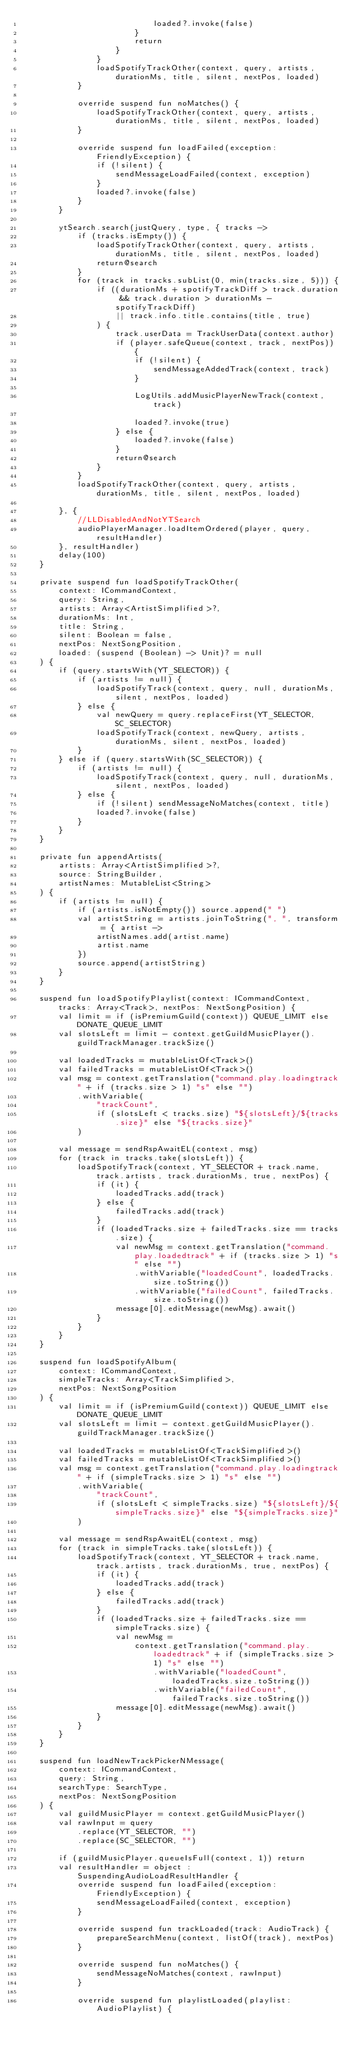<code> <loc_0><loc_0><loc_500><loc_500><_Kotlin_>                            loaded?.invoke(false)
                        }
                        return
                    }
                }
                loadSpotifyTrackOther(context, query, artists, durationMs, title, silent, nextPos, loaded)
            }

            override suspend fun noMatches() {
                loadSpotifyTrackOther(context, query, artists, durationMs, title, silent, nextPos, loaded)
            }

            override suspend fun loadFailed(exception: FriendlyException) {
                if (!silent) {
                    sendMessageLoadFailed(context, exception)
                }
                loaded?.invoke(false)
            }
        }

        ytSearch.search(justQuery, type, { tracks ->
            if (tracks.isEmpty()) {
                loadSpotifyTrackOther(context, query, artists, durationMs, title, silent, nextPos, loaded)
                return@search
            }
            for (track in tracks.subList(0, min(tracks.size, 5))) {
                if ((durationMs + spotifyTrackDiff > track.duration && track.duration > durationMs - spotifyTrackDiff)
                    || track.info.title.contains(title, true)
                ) {
                    track.userData = TrackUserData(context.author)
                    if (player.safeQueue(context, track, nextPos)) {
                        if (!silent) {
                            sendMessageAddedTrack(context, track)
                        }

                        LogUtils.addMusicPlayerNewTrack(context, track)

                        loaded?.invoke(true)
                    } else {
                        loaded?.invoke(false)
                    }
                    return@search
                }
            }
            loadSpotifyTrackOther(context, query, artists, durationMs, title, silent, nextPos, loaded)

        }, {
            //LLDisabledAndNotYTSearch
            audioPlayerManager.loadItemOrdered(player, query, resultHandler)
        }, resultHandler)
        delay(100)
    }

    private suspend fun loadSpotifyTrackOther(
        context: ICommandContext,
        query: String,
        artists: Array<ArtistSimplified>?,
        durationMs: Int,
        title: String,
        silent: Boolean = false,
        nextPos: NextSongPosition,
        loaded: (suspend (Boolean) -> Unit)? = null
    ) {
        if (query.startsWith(YT_SELECTOR)) {
            if (artists != null) {
                loadSpotifyTrack(context, query, null, durationMs, silent, nextPos, loaded)
            } else {
                val newQuery = query.replaceFirst(YT_SELECTOR, SC_SELECTOR)
                loadSpotifyTrack(context, newQuery, artists, durationMs, silent, nextPos, loaded)
            }
        } else if (query.startsWith(SC_SELECTOR)) {
            if (artists != null) {
                loadSpotifyTrack(context, query, null, durationMs, silent, nextPos, loaded)
            } else {
                if (!silent) sendMessageNoMatches(context, title)
                loaded?.invoke(false)
            }
        }
    }

    private fun appendArtists(
        artists: Array<ArtistSimplified>?,
        source: StringBuilder,
        artistNames: MutableList<String>
    ) {
        if (artists != null) {
            if (artists.isNotEmpty()) source.append(" ")
            val artistString = artists.joinToString(", ", transform = { artist ->
                artistNames.add(artist.name)
                artist.name
            })
            source.append(artistString)
        }
    }

    suspend fun loadSpotifyPlaylist(context: ICommandContext, tracks: Array<Track>, nextPos: NextSongPosition) {
        val limit = if (isPremiumGuild(context)) QUEUE_LIMIT else DONATE_QUEUE_LIMIT
        val slotsLeft = limit - context.getGuildMusicPlayer().guildTrackManager.trackSize()

        val loadedTracks = mutableListOf<Track>()
        val failedTracks = mutableListOf<Track>()
        val msg = context.getTranslation("command.play.loadingtrack" + if (tracks.size > 1) "s" else "")
            .withVariable(
                "trackCount",
                if (slotsLeft < tracks.size) "${slotsLeft}/${tracks.size}" else "${tracks.size}"
            )

        val message = sendRspAwaitEL(context, msg)
        for (track in tracks.take(slotsLeft)) {
            loadSpotifyTrack(context, YT_SELECTOR + track.name, track.artists, track.durationMs, true, nextPos) {
                if (it) {
                    loadedTracks.add(track)
                } else {
                    failedTracks.add(track)
                }
                if (loadedTracks.size + failedTracks.size == tracks.size) {
                    val newMsg = context.getTranslation("command.play.loadedtrack" + if (tracks.size > 1) "s" else "")
                        .withVariable("loadedCount", loadedTracks.size.toString())
                        .withVariable("failedCount", failedTracks.size.toString())
                    message[0].editMessage(newMsg).await()
                }
            }
        }
    }

    suspend fun loadSpotifyAlbum(
        context: ICommandContext,
        simpleTracks: Array<TrackSimplified>,
        nextPos: NextSongPosition
    ) {
        val limit = if (isPremiumGuild(context)) QUEUE_LIMIT else DONATE_QUEUE_LIMIT
        val slotsLeft = limit - context.getGuildMusicPlayer().guildTrackManager.trackSize()

        val loadedTracks = mutableListOf<TrackSimplified>()
        val failedTracks = mutableListOf<TrackSimplified>()
        val msg = context.getTranslation("command.play.loadingtrack" + if (simpleTracks.size > 1) "s" else "")
            .withVariable(
                "trackCount",
                if (slotsLeft < simpleTracks.size) "${slotsLeft}/${simpleTracks.size}" else "${simpleTracks.size}"
            )

        val message = sendRspAwaitEL(context, msg)
        for (track in simpleTracks.take(slotsLeft)) {
            loadSpotifyTrack(context, YT_SELECTOR + track.name, track.artists, track.durationMs, true, nextPos) {
                if (it) {
                    loadedTracks.add(track)
                } else {
                    failedTracks.add(track)
                }
                if (loadedTracks.size + failedTracks.size == simpleTracks.size) {
                    val newMsg =
                        context.getTranslation("command.play.loadedtrack" + if (simpleTracks.size > 1) "s" else "")
                            .withVariable("loadedCount", loadedTracks.size.toString())
                            .withVariable("failedCount", failedTracks.size.toString())
                    message[0].editMessage(newMsg).await()
                }
            }
        }
    }

    suspend fun loadNewTrackPickerNMessage(
        context: ICommandContext,
        query: String,
        searchType: SearchType,
        nextPos: NextSongPosition
    ) {
        val guildMusicPlayer = context.getGuildMusicPlayer()
        val rawInput = query
            .replace(YT_SELECTOR, "")
            .replace(SC_SELECTOR, "")

        if (guildMusicPlayer.queueIsFull(context, 1)) return
        val resultHandler = object : SuspendingAudioLoadResultHandler {
            override suspend fun loadFailed(exception: FriendlyException) {
                sendMessageLoadFailed(context, exception)
            }

            override suspend fun trackLoaded(track: AudioTrack) {
                prepareSearchMenu(context, listOf(track), nextPos)
            }

            override suspend fun noMatches() {
                sendMessageNoMatches(context, rawInput)
            }

            override suspend fun playlistLoaded(playlist: AudioPlaylist) {</code> 